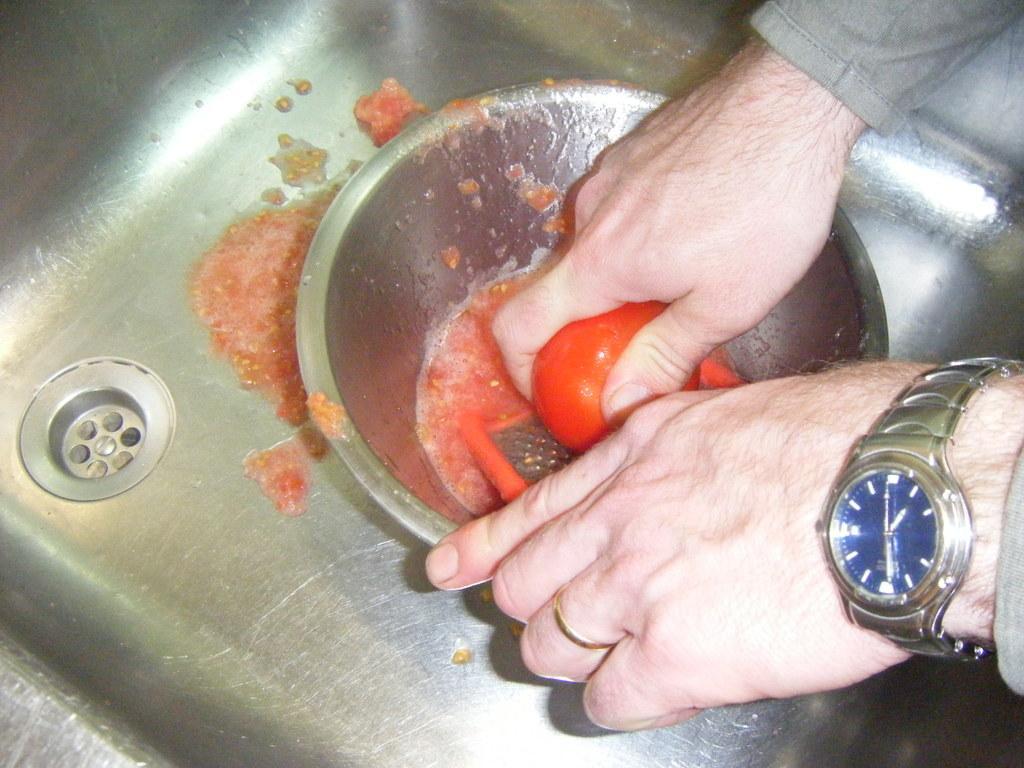How would you summarize this image in a sentence or two? This person is grating a tomato with grater in this bowl. This is sink. This person wore a wrist watch. 